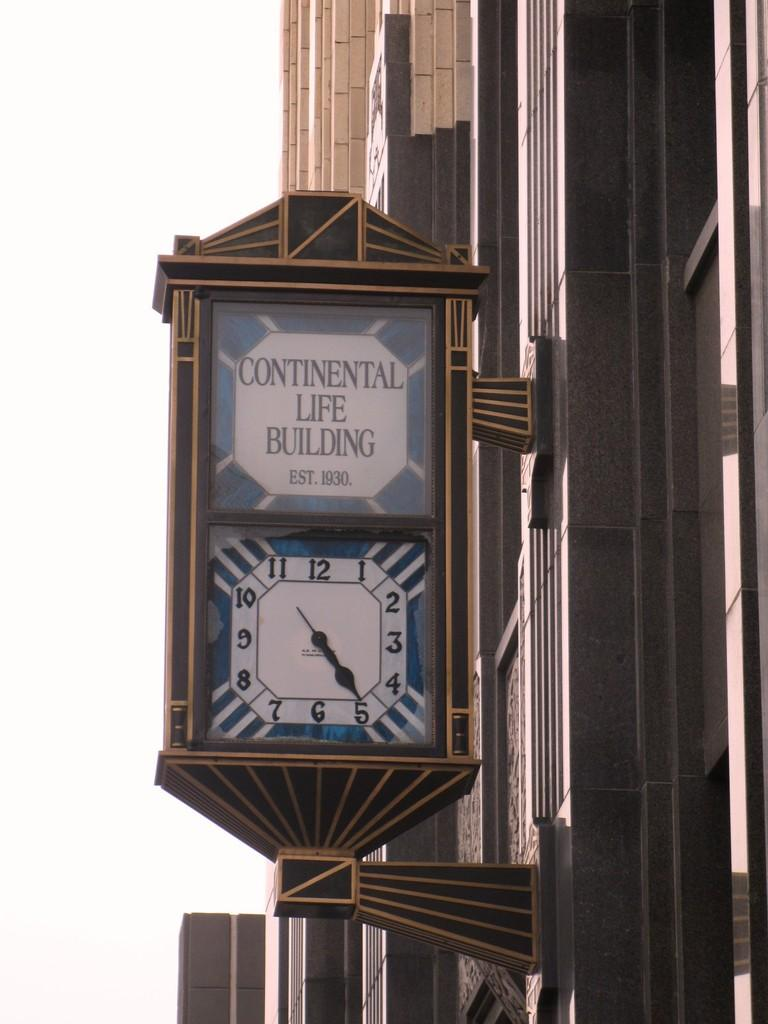<image>
Relay a brief, clear account of the picture shown. the words continental life building are above the clock 